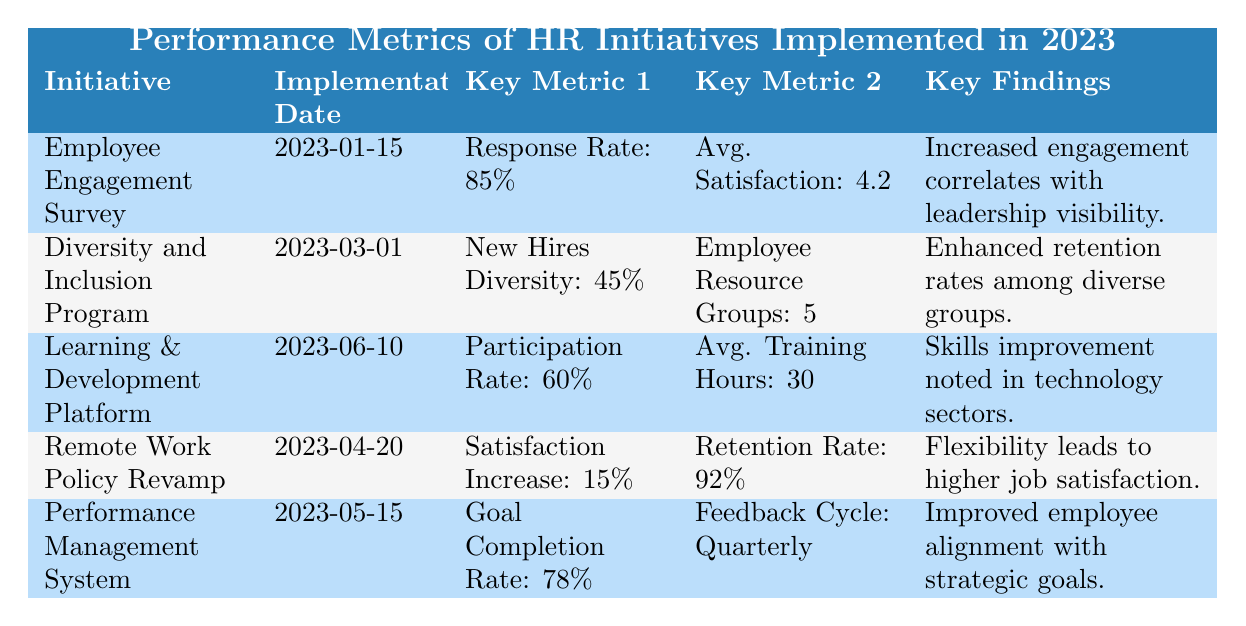What is the response rate for the Employee Engagement Survey? From the table, the response rate for the Employee Engagement Survey is clearly indicated as 85%.
Answer: 85% What is the implementation date for the Diversity and Inclusion Program? The table shows the implementation date of the Diversity and Inclusion Program as 2023-03-01.
Answer: 2023-03-01 How many Employee Resource Groups are reported for the Diversity and Inclusion Program? According to the table, there are 5 Employee Resource Groups associated with the Diversity and Inclusion Program.
Answer: 5 What is the average satisfaction score for the Employee Engagement Survey? The average satisfaction score for the Employee Engagement Survey, as stated in the table, is 4.2.
Answer: 4.2 Is the employee satisfaction increase for the Remote Work Policy Revamp greater than 10%? The employee satisfaction increase for the Remote Work Policy Revamp is 15%, which is indeed greater than 10%.
Answer: Yes Which initiative has the highest retention rate? The Remote Work Policy Revamp has a retention rate of 92%, which is higher than the other initiatives listed.
Answer: 92% What is the total participation rate for the Learning & Development Platform compared to the response rate of the Employee Engagement Survey? The participation rate for the Learning & Development Platform is 60%, while the response rate for the Employee Engagement Survey is 85%. The Employee Engagement Survey has a higher response rate than the Learning & Development Platform.
Answer: 85% > 60% Did the Performance Management System achieve a goal completion rate of over 75%? Yes, the Performance Management System achieved a goal completion rate of 78%, which is over 75%.
Answer: Yes What is the difference in average training hours per employee between the Learning & Development Platform and a hypothetical base of 20 hours? The average training hours per employee for the Learning & Development Platform is 30 hours. The difference between this and the hypothetical base of 20 hours is 30 - 20 = 10 hours.
Answer: 10 hours 